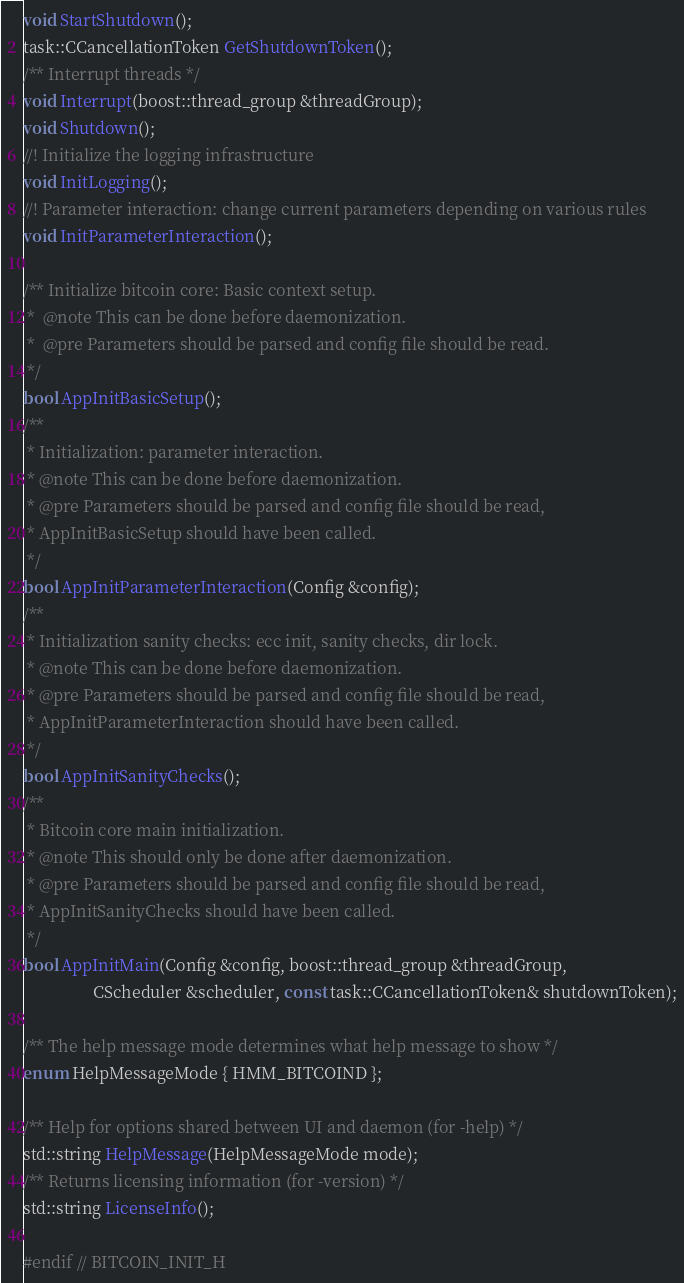Convert code to text. <code><loc_0><loc_0><loc_500><loc_500><_C_>
void StartShutdown();
task::CCancellationToken GetShutdownToken();
/** Interrupt threads */
void Interrupt(boost::thread_group &threadGroup);
void Shutdown();
//! Initialize the logging infrastructure
void InitLogging();
//! Parameter interaction: change current parameters depending on various rules
void InitParameterInteraction();

/** Initialize bitcoin core: Basic context setup.
 *  @note This can be done before daemonization.
 *  @pre Parameters should be parsed and config file should be read.
 */
bool AppInitBasicSetup();
/**
 * Initialization: parameter interaction.
 * @note This can be done before daemonization.
 * @pre Parameters should be parsed and config file should be read,
 * AppInitBasicSetup should have been called.
 */
bool AppInitParameterInteraction(Config &config);
/**
 * Initialization sanity checks: ecc init, sanity checks, dir lock.
 * @note This can be done before daemonization.
 * @pre Parameters should be parsed and config file should be read,
 * AppInitParameterInteraction should have been called.
 */
bool AppInitSanityChecks();
/**
 * Bitcoin core main initialization.
 * @note This should only be done after daemonization.
 * @pre Parameters should be parsed and config file should be read,
 * AppInitSanityChecks should have been called.
 */
bool AppInitMain(Config &config, boost::thread_group &threadGroup,
                 CScheduler &scheduler, const task::CCancellationToken& shutdownToken);

/** The help message mode determines what help message to show */
enum HelpMessageMode { HMM_BITCOIND };

/** Help for options shared between UI and daemon (for -help) */
std::string HelpMessage(HelpMessageMode mode);
/** Returns licensing information (for -version) */
std::string LicenseInfo();

#endif // BITCOIN_INIT_H
</code> 